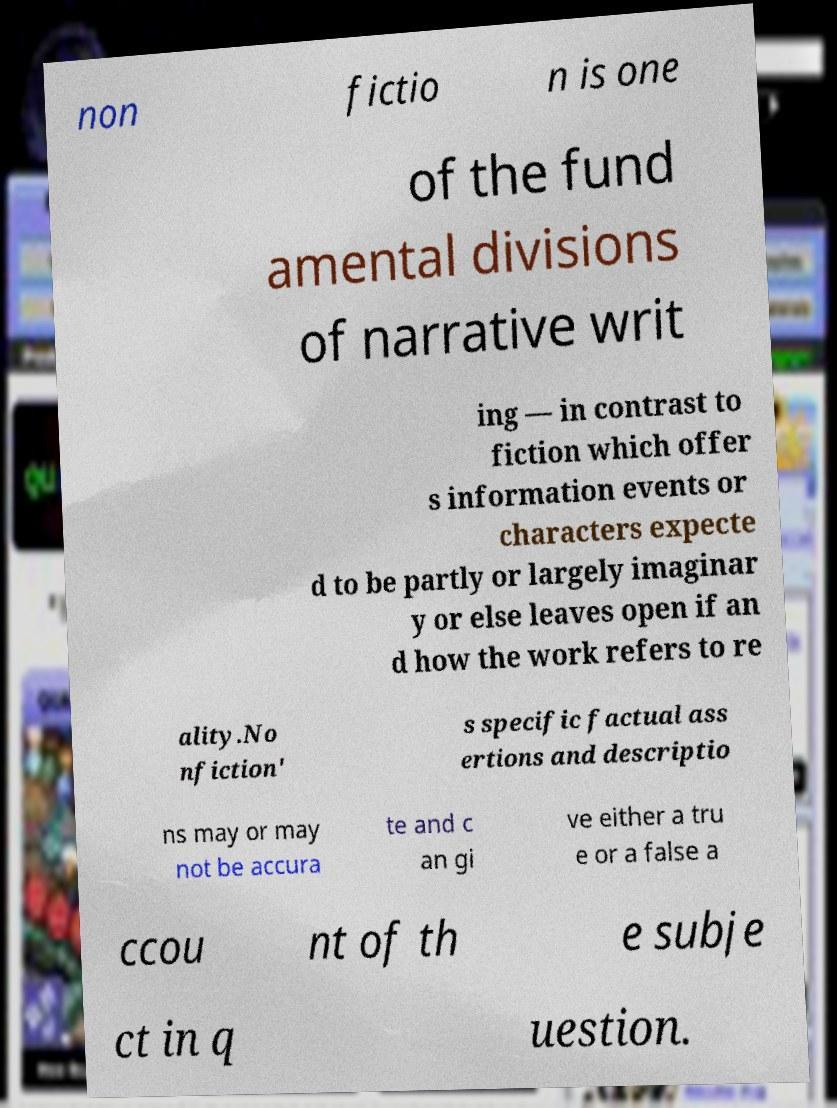Please identify and transcribe the text found in this image. non fictio n is one of the fund amental divisions of narrative writ ing — in contrast to fiction which offer s information events or characters expecte d to be partly or largely imaginar y or else leaves open if an d how the work refers to re ality.No nfiction' s specific factual ass ertions and descriptio ns may or may not be accura te and c an gi ve either a tru e or a false a ccou nt of th e subje ct in q uestion. 